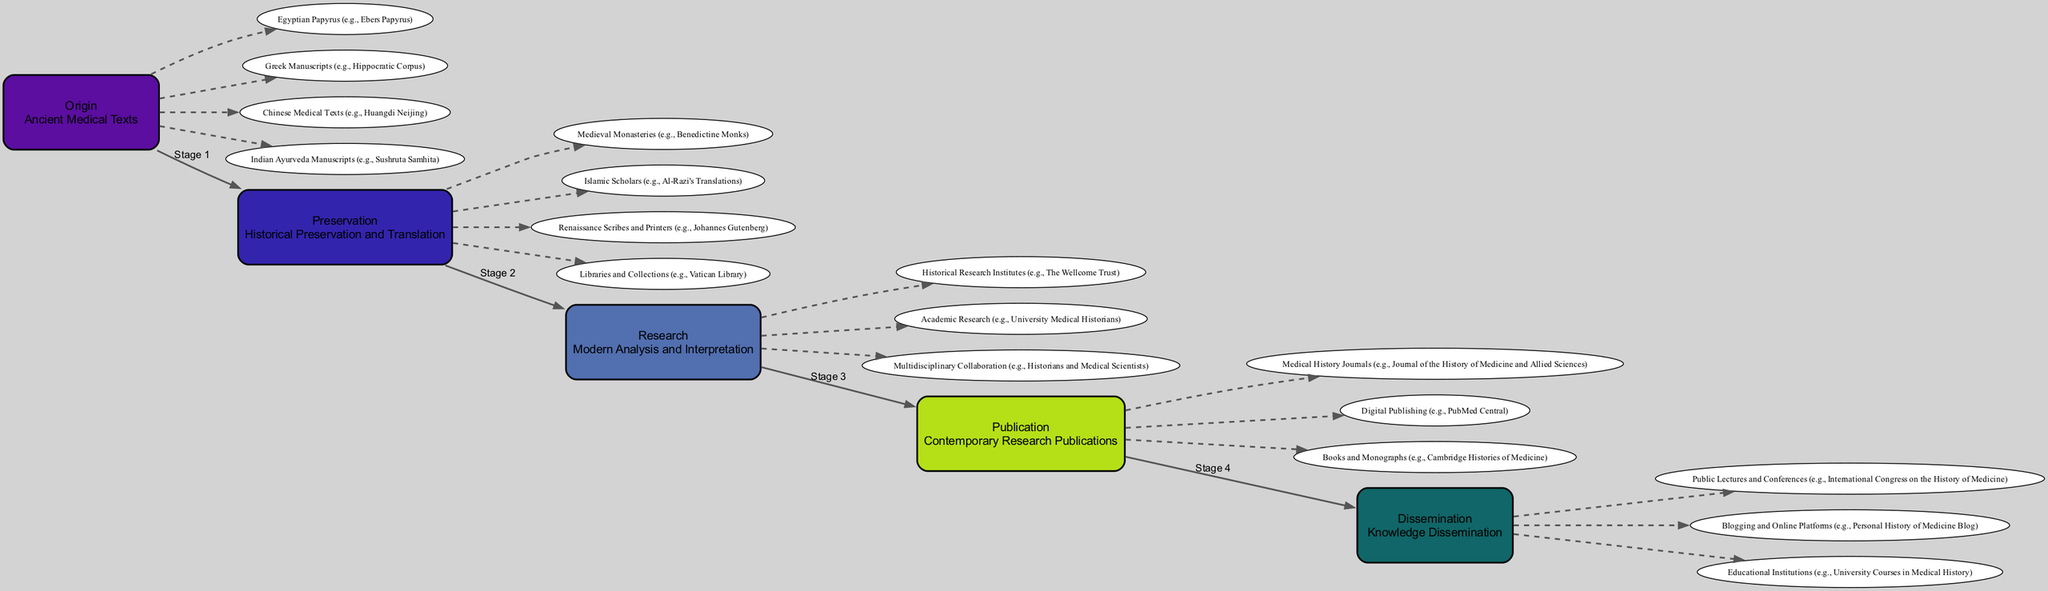What is the first stage in the journey of a medical manuscript? The first stage is labeled as "Origin" in the diagram, which includes descriptions and components representing ancient medical texts.
Answer: Origin How many components are listed under the "Preservation" stage? The "Preservation" stage lists four components: Medieval Monasteries, Islamic Scholars, Renaissance Scribes and Printers, and Libraries and Collections. By counting each of them, we confirm that there are four.
Answer: 4 Which component is associated with the "Publication" stage? The "Publication" stage includes multiple components, one of which is the "Medical History Journals," which represents part of contemporary research publications.
Answer: Medical History Journals What is the relationship between "Research" and "Publication"? In the flow chart, the "Research" stage flows into the "Publication" stage, indicating that research activities contribute to the publication of findings.
Answer: Flow Which stage includes the Wellcome Trust as a component? The "Research" stage includes the Wellcome Trust as one of its key components, representing modern analysis and interpretation of medical texts.
Answer: Research How many stages are listed in the journey of a medical manuscript? The diagram outlines five distinct stages in the journey, from "Origin" to "Dissemination," which can be counted directly from the diagram.
Answer: 5 What is a common method for knowledge dissemination identified in the final stage? In the "Dissemination" stage, one identified method is "Public Lectures and Conferences," which reflects how knowledge is shared with the public.
Answer: Public Lectures and Conferences What type of historical institution is involved in the "Research" stage? The "Research" stage includes historical research institutes, exemplified by the Wellcome Trust, which focuses on medical and historical research.
Answer: Historical research institutes Which component connects the "Preservation" stage to the "Research" stage? The connection between "Preservation" and "Research" is represented by the transition of historical texts preserved by scholars into modern analysis by historians.
Answer: Transition of preserved texts 